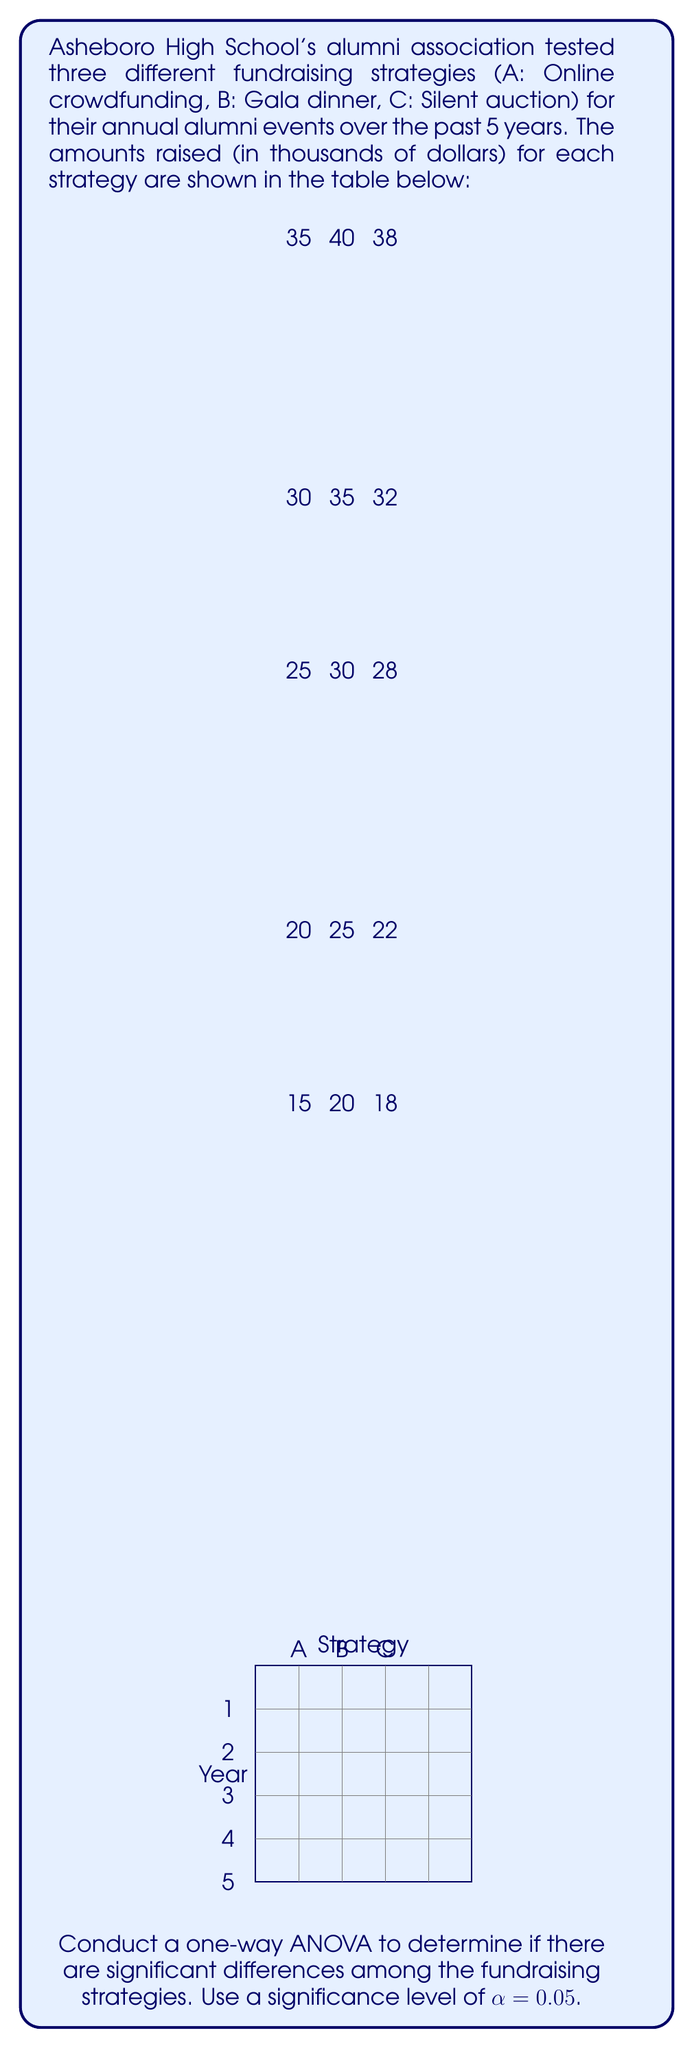Provide a solution to this math problem. To conduct a one-way ANOVA, we'll follow these steps:

1) Calculate the sum of squares:

   SST (Total) = ∑(x - x̄)²
   SSB (Between) = ∑n_i(x̄_i - x̄)²
   SSW (Within) = SST - SSB

2) Calculate degrees of freedom:
   
   dfB = k - 1 (where k is the number of groups)
   dfW = N - k (where N is the total number of observations)
   dfT = N - 1

3) Calculate mean squares:
   
   MSB = SSB / dfB
   MSW = SSW / dfW

4) Calculate F-statistic:
   
   F = MSB / MSW

5) Compare F to the critical F-value

Step 1: Calculate sums and means

Strategy A: Sum = 100, Mean = 20
Strategy B: Sum = 175, Mean = 35
Strategy C: Sum = 150, Mean = 30
Overall Mean = (100 + 175 + 150) / 15 = 28.33

Step 2: Calculate SS

SST = ∑(x - 28.33)² = 1266.67
SSB = 5[(20 - 28.33)² + (35 - 28.33)² + (30 - 28.33)²] = 550
SSW = 1266.67 - 550 = 716.67

Step 3: Calculate df

dfB = 3 - 1 = 2
dfW = 15 - 3 = 12
dfT = 15 - 1 = 14

Step 4: Calculate MS

MSB = 550 / 2 = 275
MSW = 716.67 / 12 = 59.72

Step 5: Calculate F-statistic

F = 275 / 59.72 = 4.60

Step 6: Find critical F-value

For α = 0.05, dfB = 2, and dfW = 12, the critical F-value is approximately 3.89.

Step 7: Compare F-statistic to critical F-value

Since 4.60 > 3.89, we reject the null hypothesis.
Answer: F(2,12) = 4.60, p < 0.05. Significant differences exist among fundraising strategies. 